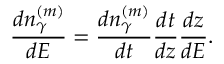<formula> <loc_0><loc_0><loc_500><loc_500>\frac { d n _ { \gamma } ^ { ( m ) } } { d E } = \frac { d n _ { \gamma } ^ { ( m ) } } { d t } \frac { d t } { d z } \frac { d z } { d E } .</formula> 